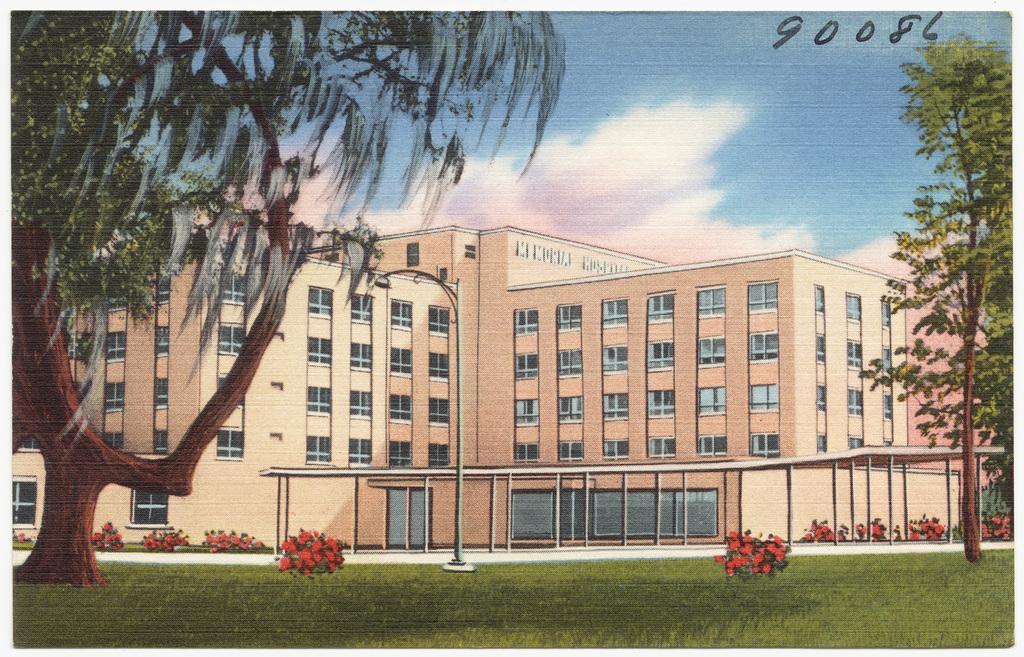In one or two sentences, can you explain what this image depicts? This is a poster. There is grass in the bottom and there are small bushes in the bottom. There are trees on the left side and right side. In the middle there is a building. There is sky in the top. There are windows to the buildings. 